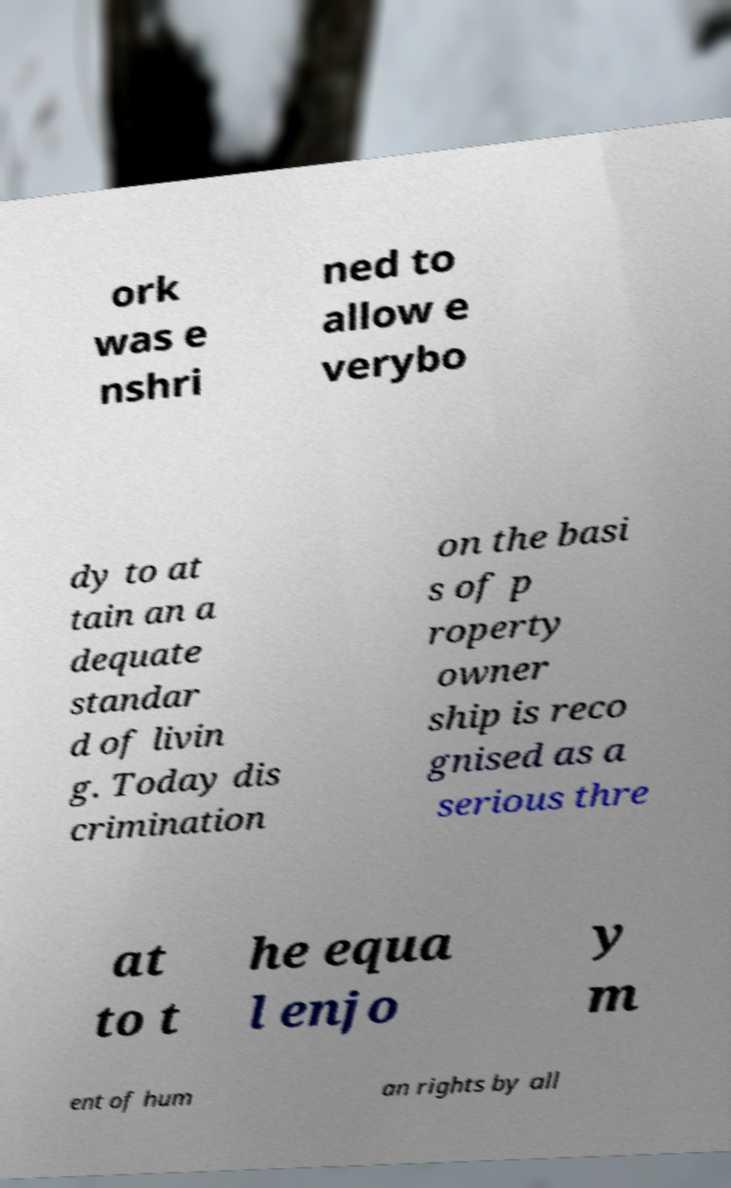Please read and relay the text visible in this image. What does it say? ork was e nshri ned to allow e verybo dy to at tain an a dequate standar d of livin g. Today dis crimination on the basi s of p roperty owner ship is reco gnised as a serious thre at to t he equa l enjo y m ent of hum an rights by all 